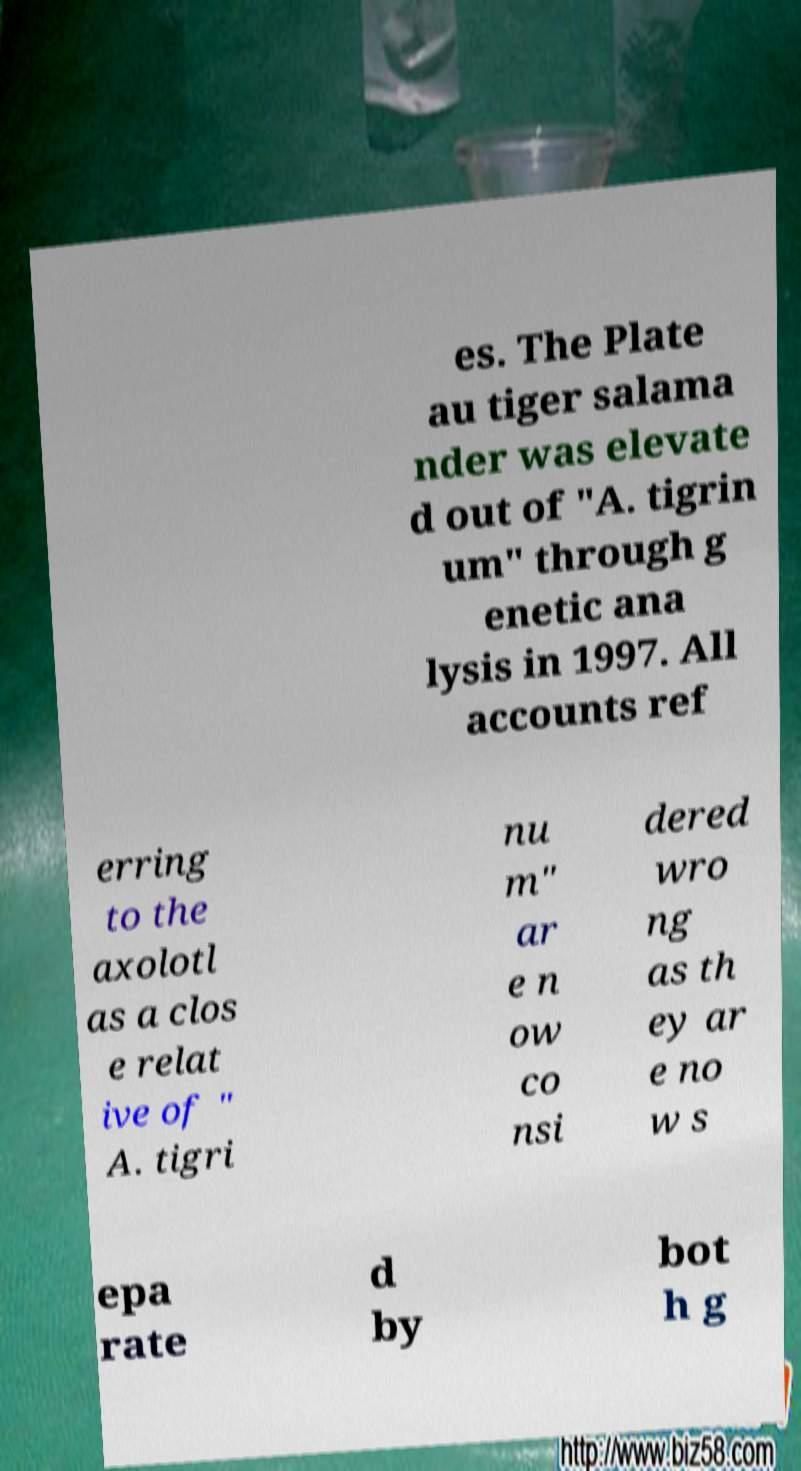I need the written content from this picture converted into text. Can you do that? es. The Plate au tiger salama nder was elevate d out of "A. tigrin um" through g enetic ana lysis in 1997. All accounts ref erring to the axolotl as a clos e relat ive of " A. tigri nu m" ar e n ow co nsi dered wro ng as th ey ar e no w s epa rate d by bot h g 